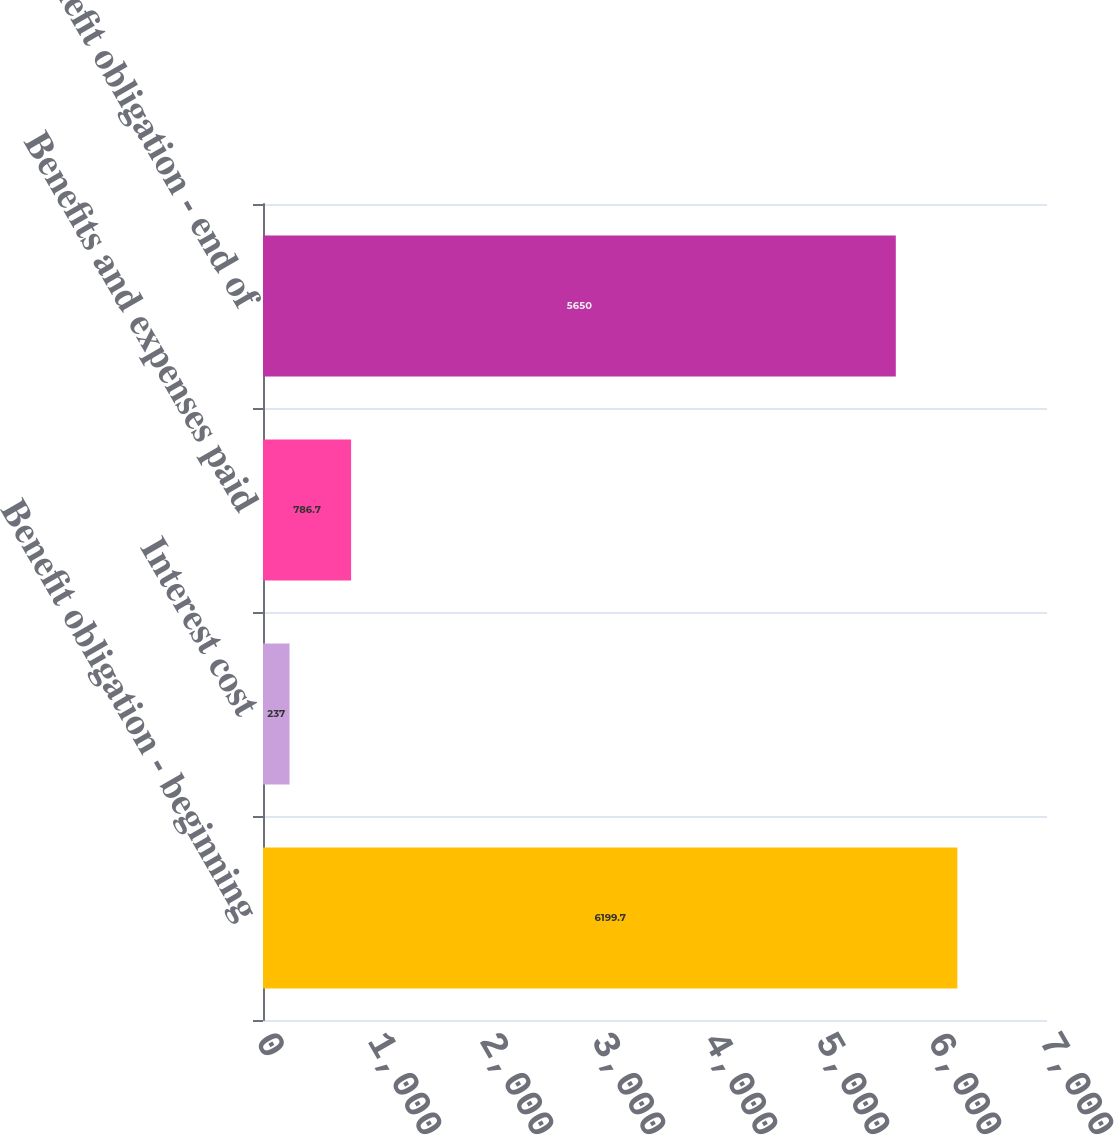Convert chart. <chart><loc_0><loc_0><loc_500><loc_500><bar_chart><fcel>Benefit obligation - beginning<fcel>Interest cost<fcel>Benefits and expenses paid<fcel>Benefit obligation - end of<nl><fcel>6199.7<fcel>237<fcel>786.7<fcel>5650<nl></chart> 